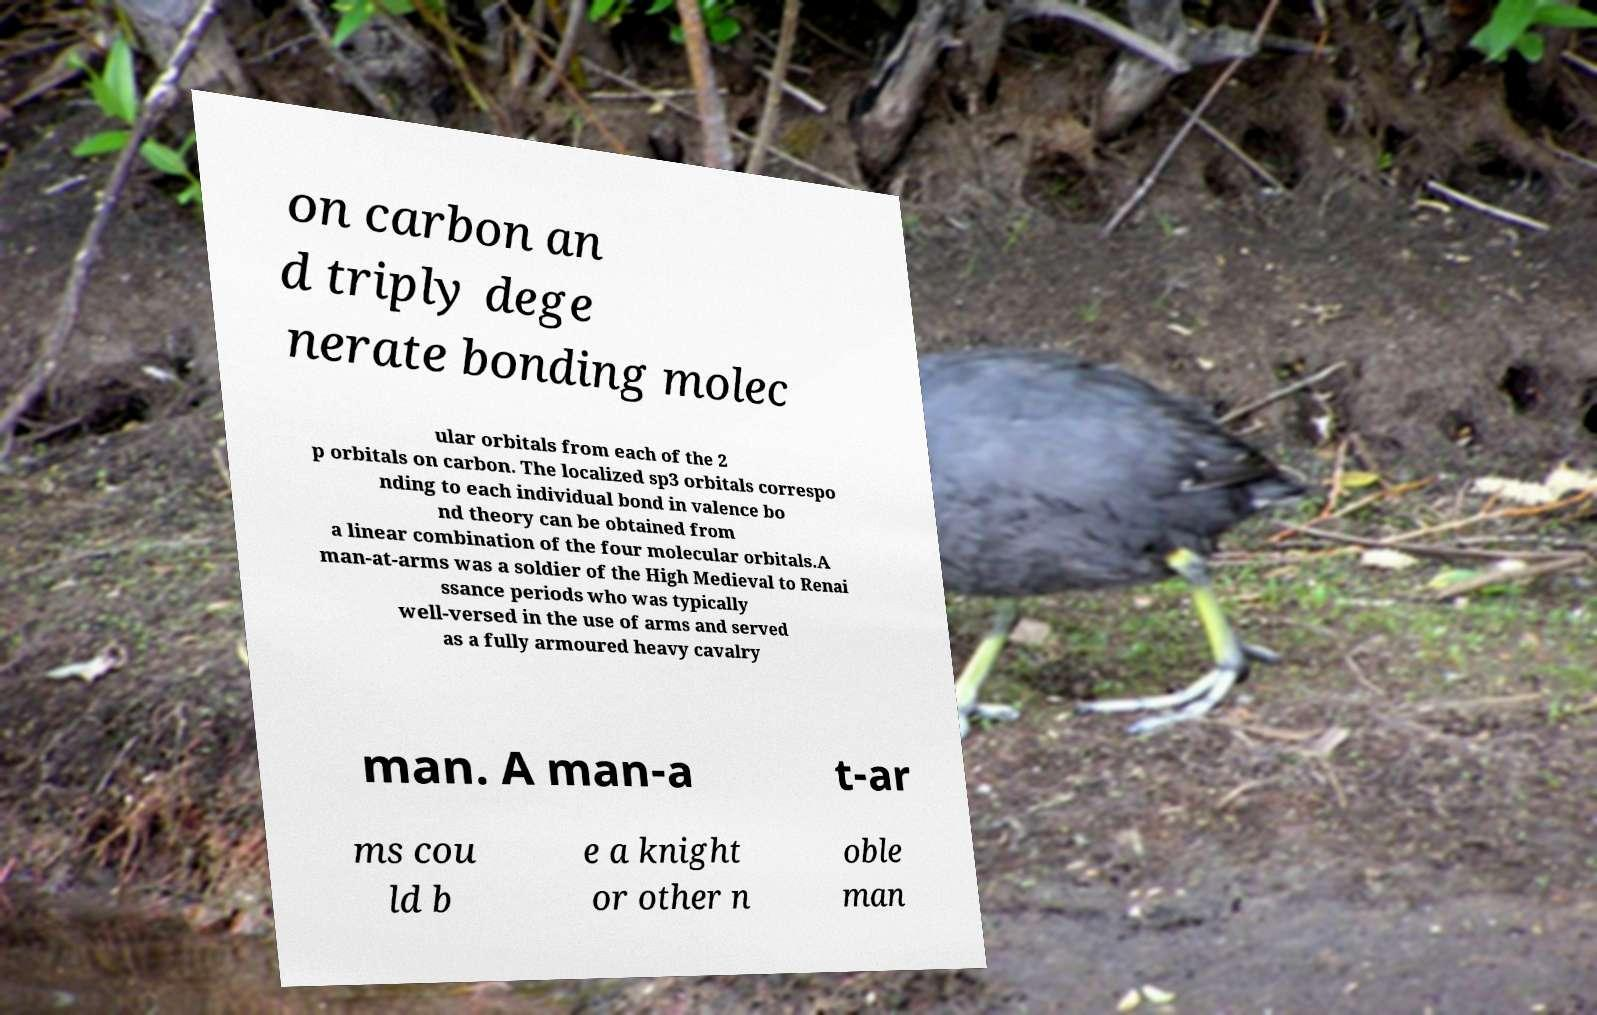Can you accurately transcribe the text from the provided image for me? on carbon an d triply dege nerate bonding molec ular orbitals from each of the 2 p orbitals on carbon. The localized sp3 orbitals correspo nding to each individual bond in valence bo nd theory can be obtained from a linear combination of the four molecular orbitals.A man-at-arms was a soldier of the High Medieval to Renai ssance periods who was typically well-versed in the use of arms and served as a fully armoured heavy cavalry man. A man-a t-ar ms cou ld b e a knight or other n oble man 